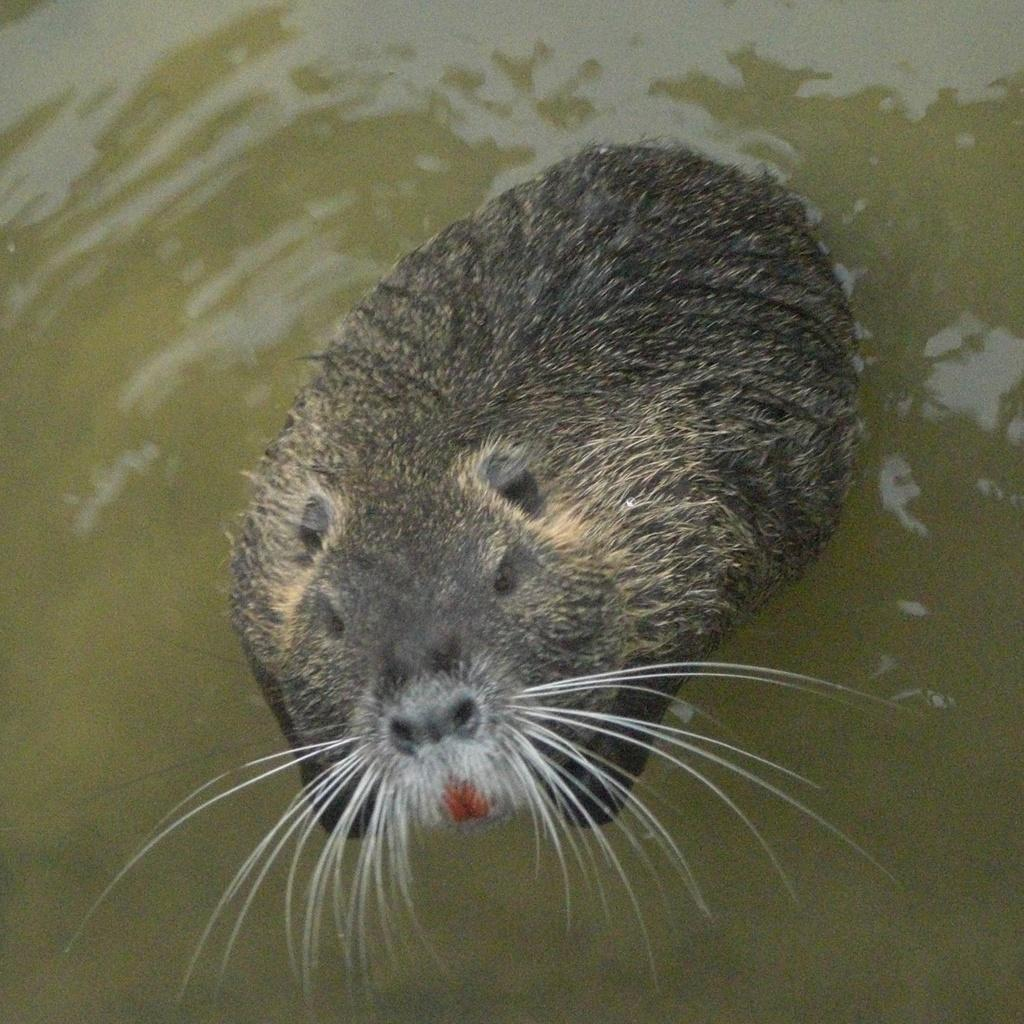What animal is present in the picture? There is a rat in the picture. What is the rat doing in the picture? The rat is swimming in the water. Can you describe any unique features of the rat? The rat has a mustache. What type of oatmeal is the rat eating in the picture? There is no oatmeal present in the image; the rat is swimming in the water. How big is the rat compared to the size of the water? The size of the rat cannot be determined in relation to the water without additional information. 